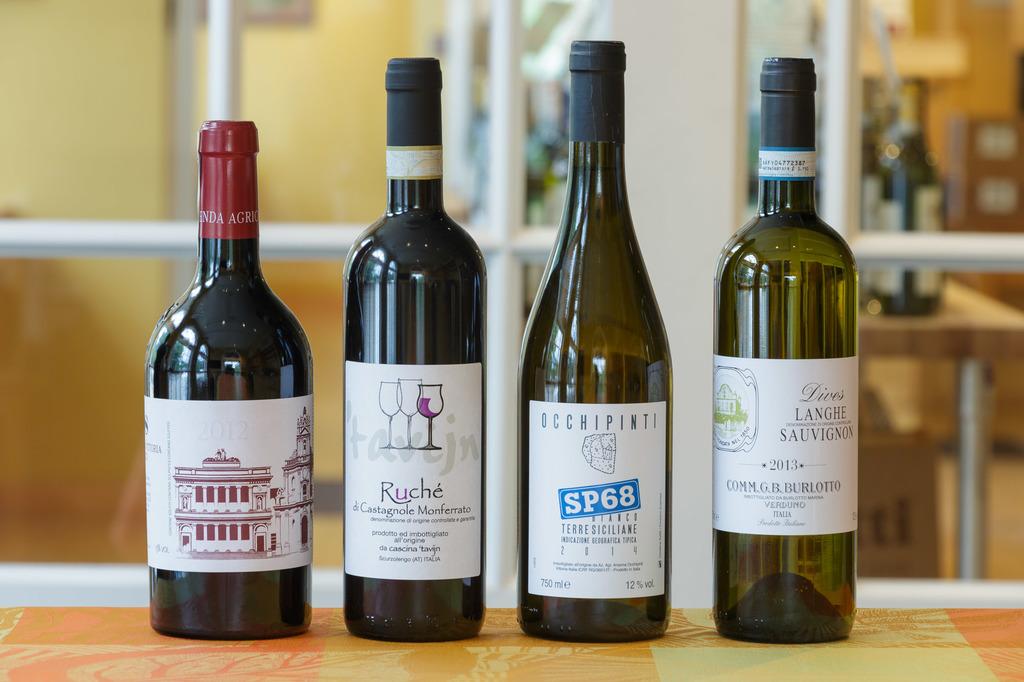What is the name of the wine second to the right?
Your answer should be very brief. Sp68. 